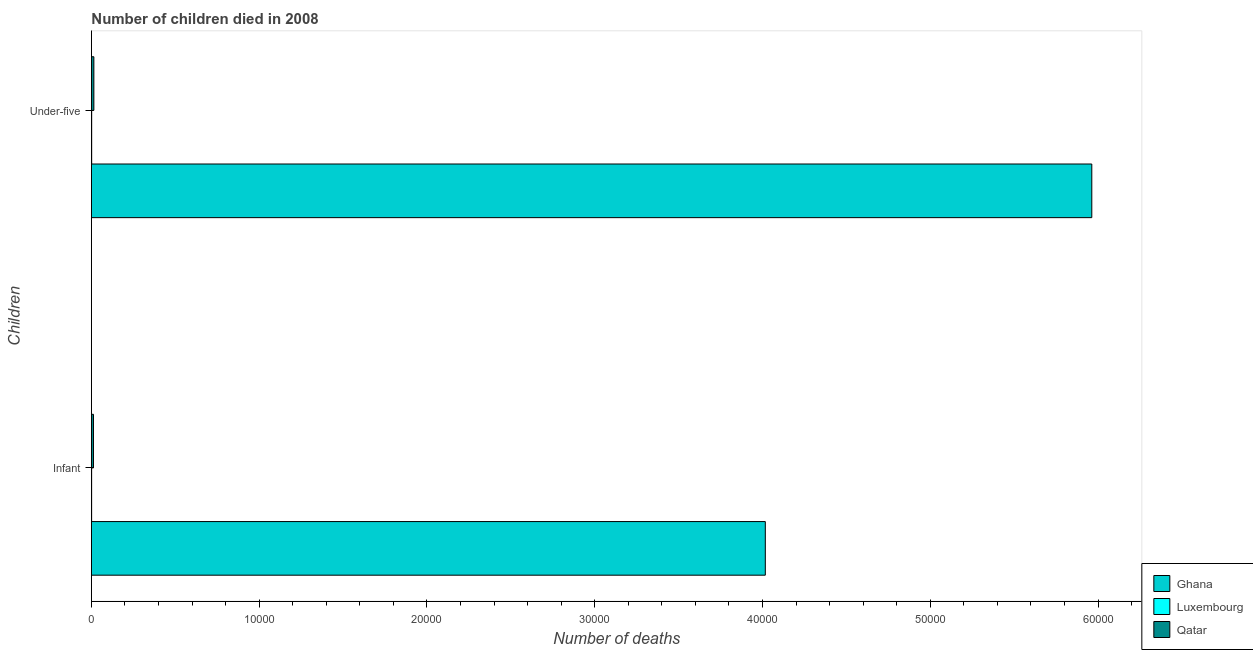How many different coloured bars are there?
Offer a very short reply. 3. How many groups of bars are there?
Offer a very short reply. 2. How many bars are there on the 1st tick from the top?
Your answer should be compact. 3. What is the label of the 1st group of bars from the top?
Offer a very short reply. Under-five. What is the number of infant deaths in Qatar?
Offer a terse response. 122. Across all countries, what is the maximum number of under-five deaths?
Your answer should be compact. 5.96e+04. Across all countries, what is the minimum number of infant deaths?
Offer a terse response. 12. In which country was the number of under-five deaths minimum?
Give a very brief answer. Luxembourg. What is the total number of under-five deaths in the graph?
Make the answer very short. 5.98e+04. What is the difference between the number of under-five deaths in Qatar and that in Luxembourg?
Your answer should be very brief. 130. What is the difference between the number of under-five deaths in Luxembourg and the number of infant deaths in Qatar?
Offer a terse response. -107. What is the average number of infant deaths per country?
Give a very brief answer. 1.34e+04. What is the difference between the number of under-five deaths and number of infant deaths in Luxembourg?
Give a very brief answer. 3. What is the ratio of the number of infant deaths in Ghana to that in Luxembourg?
Make the answer very short. 3347.25. What does the 2nd bar from the top in Under-five represents?
Your answer should be very brief. Luxembourg. What does the 2nd bar from the bottom in Infant represents?
Provide a succinct answer. Luxembourg. How many bars are there?
Provide a succinct answer. 6. Are all the bars in the graph horizontal?
Your answer should be very brief. Yes. How many countries are there in the graph?
Your answer should be compact. 3. What is the difference between two consecutive major ticks on the X-axis?
Your response must be concise. 10000. Are the values on the major ticks of X-axis written in scientific E-notation?
Make the answer very short. No. Does the graph contain any zero values?
Ensure brevity in your answer.  No. Does the graph contain grids?
Your response must be concise. No. Where does the legend appear in the graph?
Your answer should be very brief. Bottom right. How are the legend labels stacked?
Your answer should be compact. Vertical. What is the title of the graph?
Offer a very short reply. Number of children died in 2008. What is the label or title of the X-axis?
Provide a succinct answer. Number of deaths. What is the label or title of the Y-axis?
Give a very brief answer. Children. What is the Number of deaths of Ghana in Infant?
Your answer should be very brief. 4.02e+04. What is the Number of deaths in Luxembourg in Infant?
Offer a very short reply. 12. What is the Number of deaths in Qatar in Infant?
Offer a terse response. 122. What is the Number of deaths of Ghana in Under-five?
Make the answer very short. 5.96e+04. What is the Number of deaths in Qatar in Under-five?
Keep it short and to the point. 145. Across all Children, what is the maximum Number of deaths in Ghana?
Keep it short and to the point. 5.96e+04. Across all Children, what is the maximum Number of deaths of Luxembourg?
Offer a very short reply. 15. Across all Children, what is the maximum Number of deaths of Qatar?
Give a very brief answer. 145. Across all Children, what is the minimum Number of deaths in Ghana?
Provide a short and direct response. 4.02e+04. Across all Children, what is the minimum Number of deaths of Luxembourg?
Make the answer very short. 12. Across all Children, what is the minimum Number of deaths in Qatar?
Offer a very short reply. 122. What is the total Number of deaths in Ghana in the graph?
Provide a succinct answer. 9.98e+04. What is the total Number of deaths of Luxembourg in the graph?
Provide a short and direct response. 27. What is the total Number of deaths in Qatar in the graph?
Give a very brief answer. 267. What is the difference between the Number of deaths of Ghana in Infant and that in Under-five?
Give a very brief answer. -1.95e+04. What is the difference between the Number of deaths of Ghana in Infant and the Number of deaths of Luxembourg in Under-five?
Make the answer very short. 4.02e+04. What is the difference between the Number of deaths of Ghana in Infant and the Number of deaths of Qatar in Under-five?
Provide a succinct answer. 4.00e+04. What is the difference between the Number of deaths of Luxembourg in Infant and the Number of deaths of Qatar in Under-five?
Your answer should be compact. -133. What is the average Number of deaths in Ghana per Children?
Offer a terse response. 4.99e+04. What is the average Number of deaths of Luxembourg per Children?
Make the answer very short. 13.5. What is the average Number of deaths of Qatar per Children?
Provide a succinct answer. 133.5. What is the difference between the Number of deaths of Ghana and Number of deaths of Luxembourg in Infant?
Make the answer very short. 4.02e+04. What is the difference between the Number of deaths in Ghana and Number of deaths in Qatar in Infant?
Keep it short and to the point. 4.00e+04. What is the difference between the Number of deaths in Luxembourg and Number of deaths in Qatar in Infant?
Ensure brevity in your answer.  -110. What is the difference between the Number of deaths of Ghana and Number of deaths of Luxembourg in Under-five?
Provide a succinct answer. 5.96e+04. What is the difference between the Number of deaths in Ghana and Number of deaths in Qatar in Under-five?
Make the answer very short. 5.95e+04. What is the difference between the Number of deaths in Luxembourg and Number of deaths in Qatar in Under-five?
Your response must be concise. -130. What is the ratio of the Number of deaths of Ghana in Infant to that in Under-five?
Keep it short and to the point. 0.67. What is the ratio of the Number of deaths of Luxembourg in Infant to that in Under-five?
Your answer should be compact. 0.8. What is the ratio of the Number of deaths in Qatar in Infant to that in Under-five?
Your answer should be compact. 0.84. What is the difference between the highest and the second highest Number of deaths of Ghana?
Your response must be concise. 1.95e+04. What is the difference between the highest and the second highest Number of deaths of Qatar?
Keep it short and to the point. 23. What is the difference between the highest and the lowest Number of deaths of Ghana?
Ensure brevity in your answer.  1.95e+04. 